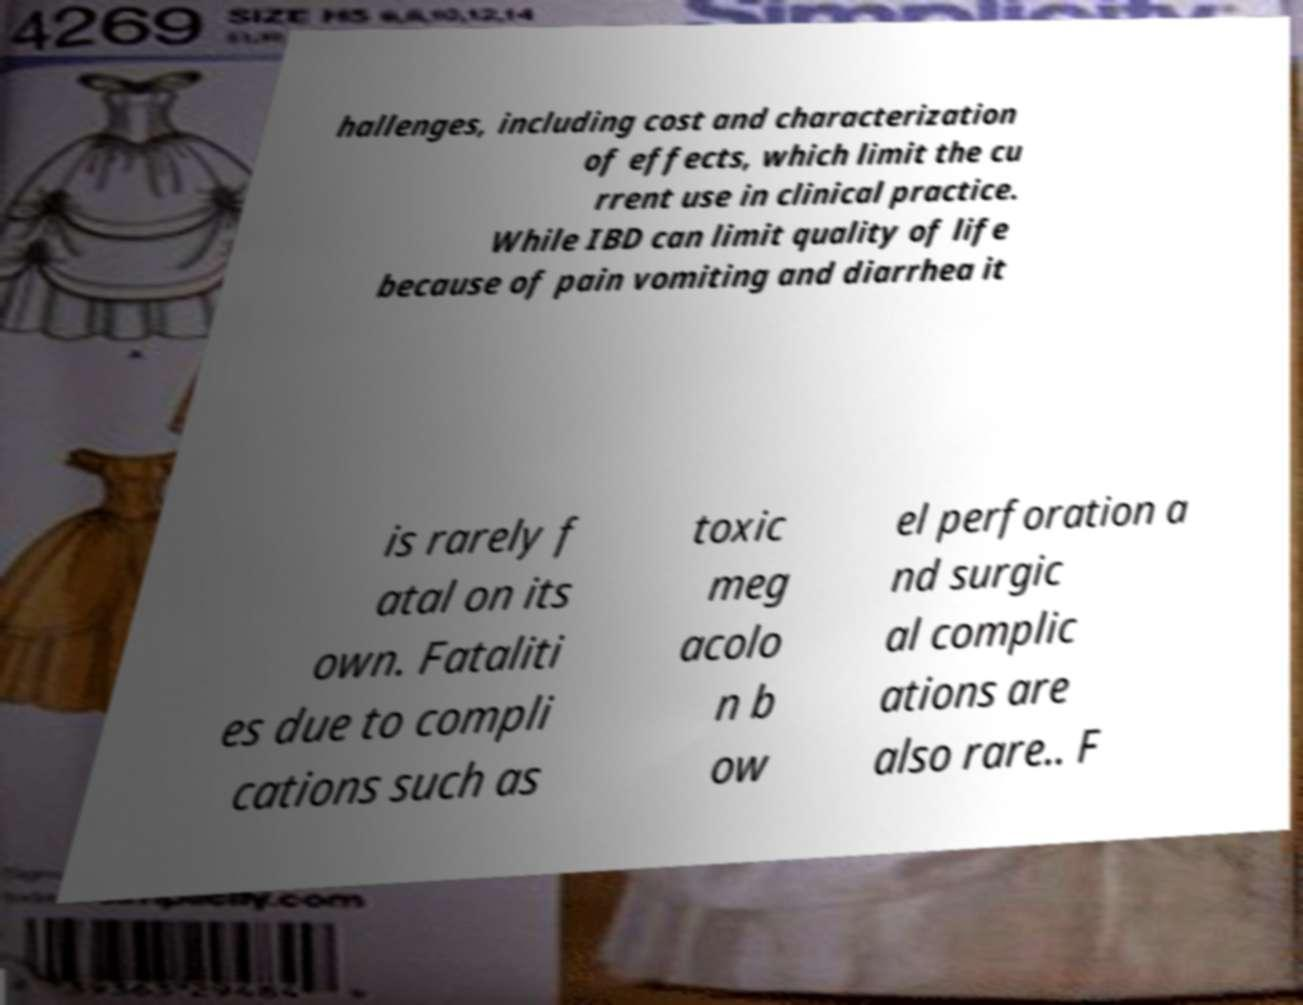Could you assist in decoding the text presented in this image and type it out clearly? hallenges, including cost and characterization of effects, which limit the cu rrent use in clinical practice. While IBD can limit quality of life because of pain vomiting and diarrhea it is rarely f atal on its own. Fataliti es due to compli cations such as toxic meg acolo n b ow el perforation a nd surgic al complic ations are also rare.. F 